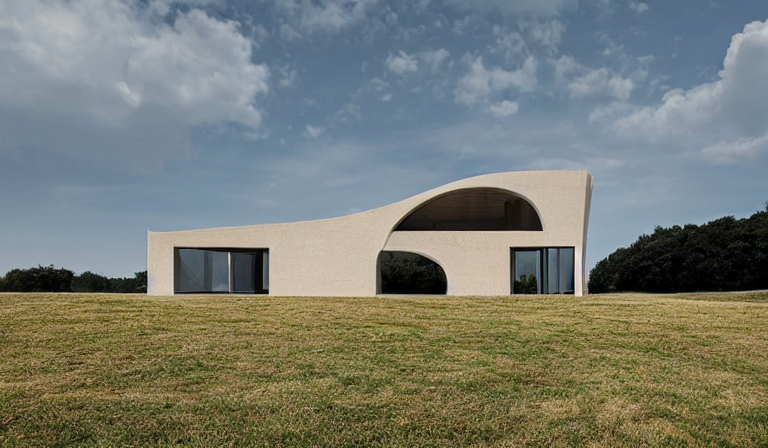Could you tell me more about the materials used in this construction? Based on the image, the building appears to employ a facade of smooth, light-colored material which might be stucco or a type of render, and extensive glass panels for the windows. These materials are often chosen for their aesthetic appeal and ability to blend with natural settings. 